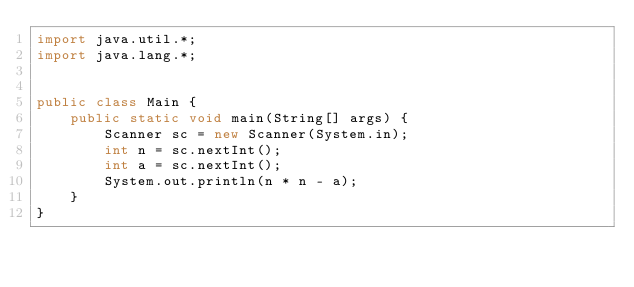Convert code to text. <code><loc_0><loc_0><loc_500><loc_500><_Java_>import java.util.*;
import java.lang.*;


public class Main {
    public static void main(String[] args) {
        Scanner sc = new Scanner(System.in);
        int n = sc.nextInt();
        int a = sc.nextInt();
        System.out.println(n * n - a);
    }
}
</code> 